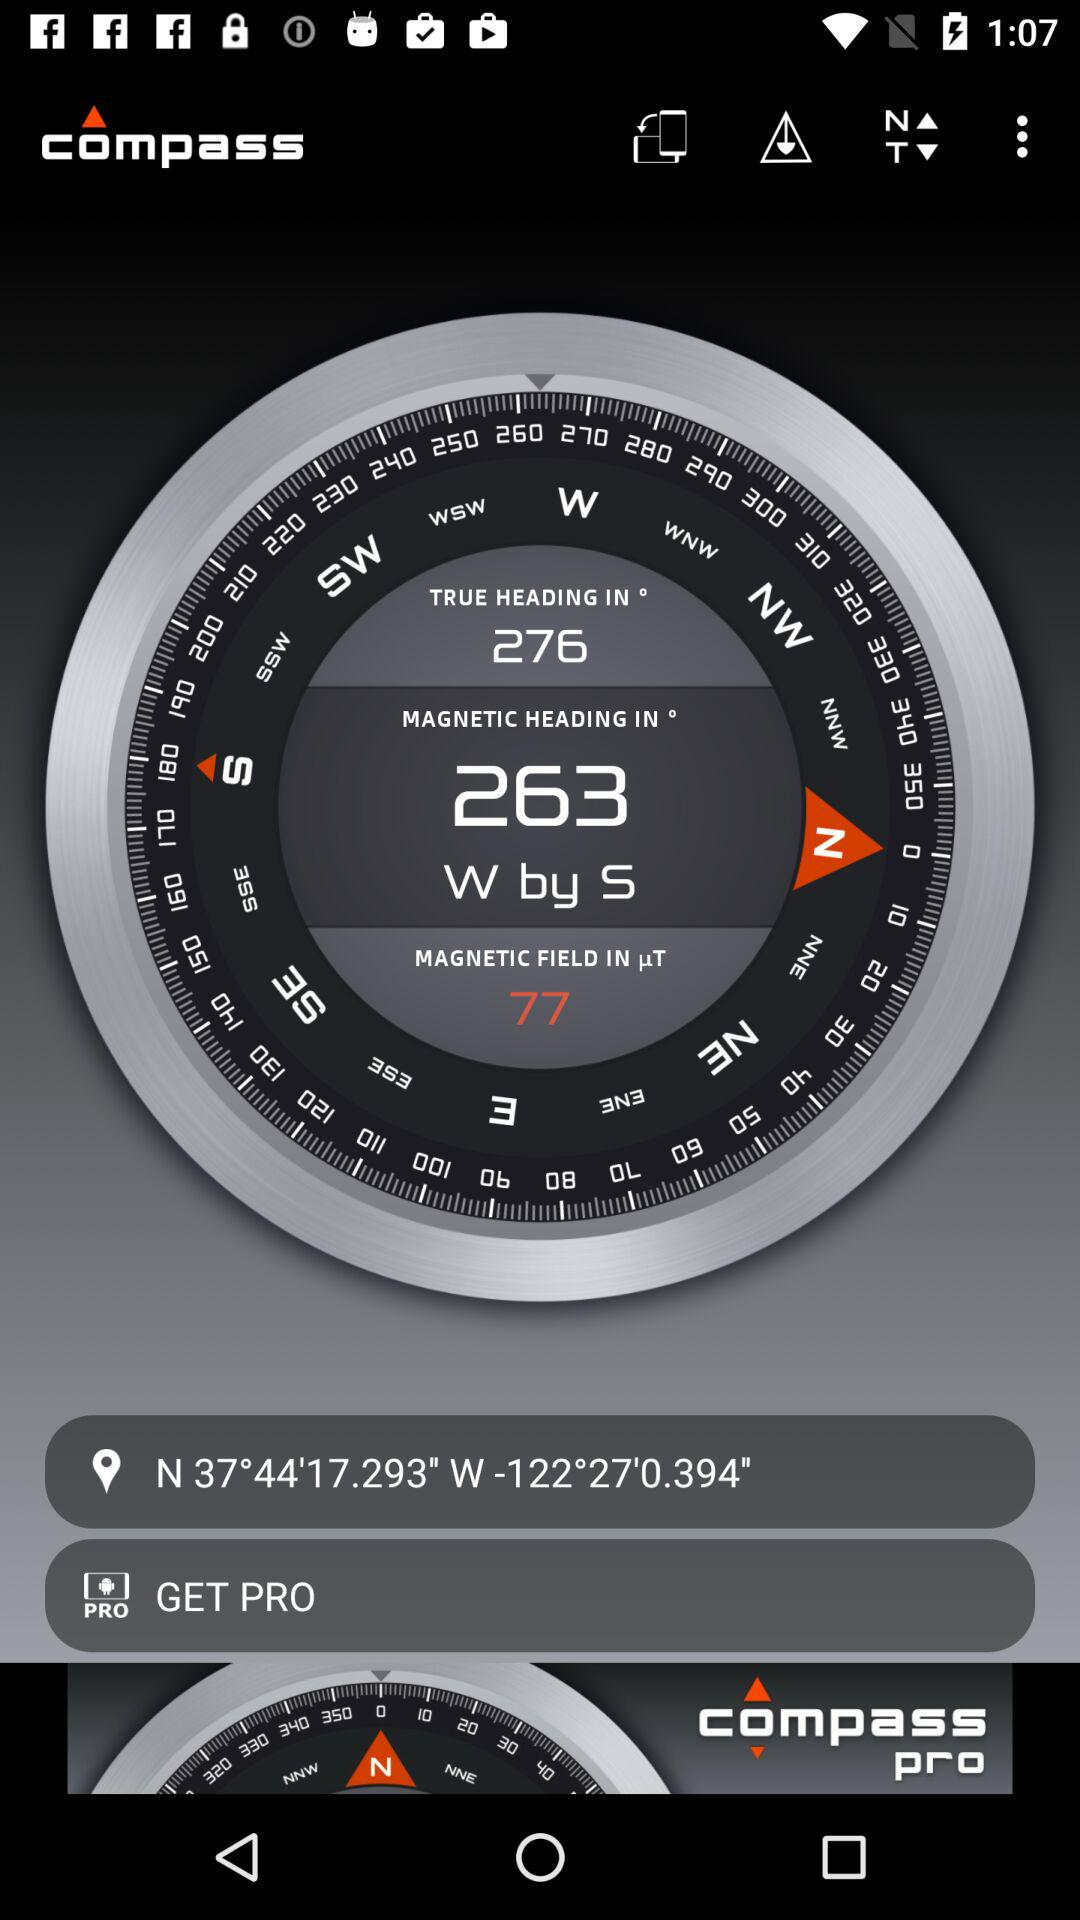Through which applications can this be shared?
When the provided information is insufficient, respond with <no answer>. <no answer> 